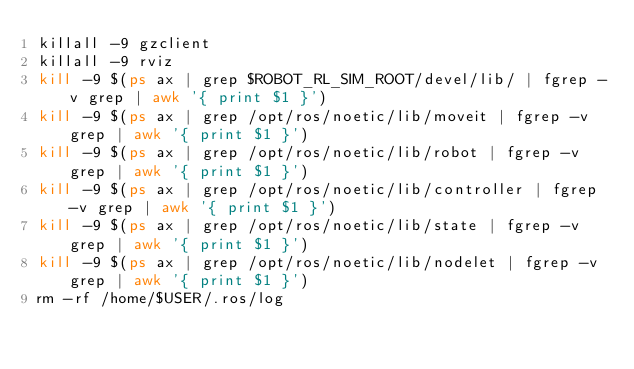Convert code to text. <code><loc_0><loc_0><loc_500><loc_500><_Bash_>killall -9 gzclient
killall -9 rviz
kill -9 $(ps ax | grep $ROBOT_RL_SIM_ROOT/devel/lib/ | fgrep -v grep | awk '{ print $1 }')
kill -9 $(ps ax | grep /opt/ros/noetic/lib/moveit | fgrep -v grep | awk '{ print $1 }')
kill -9 $(ps ax | grep /opt/ros/noetic/lib/robot | fgrep -v grep | awk '{ print $1 }')
kill -9 $(ps ax | grep /opt/ros/noetic/lib/controller | fgrep -v grep | awk '{ print $1 }')
kill -9 $(ps ax | grep /opt/ros/noetic/lib/state | fgrep -v grep | awk '{ print $1 }')
kill -9 $(ps ax | grep /opt/ros/noetic/lib/nodelet | fgrep -v grep | awk '{ print $1 }')
rm -rf /home/$USER/.ros/log
</code> 